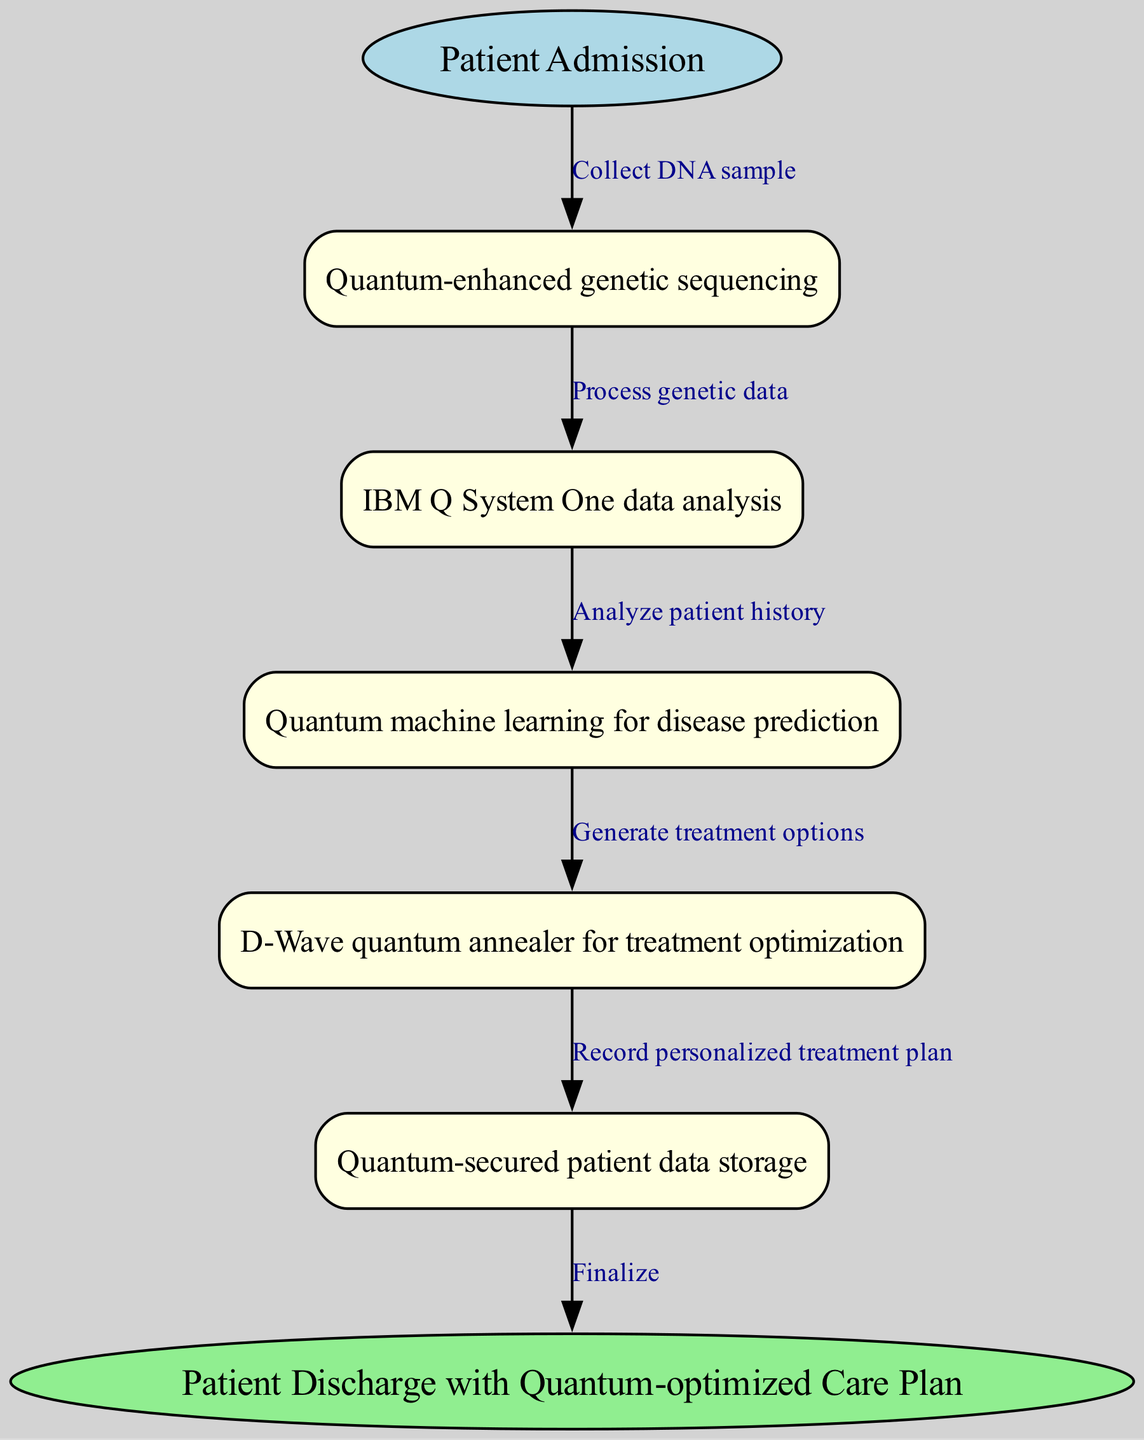What is the first step in the clinical pathway? The first step in the clinical pathway is labeled as "Patient Admission" and leads to the collection of a DNA sample.
Answer: Patient Admission How many nodes are in the diagram? The diagram contains five distinct nodes representing different processes in the pathway.
Answer: Five What is the relationship between "Quantum-enhanced genetic sequencing" and "IBM Q System One data analysis"? The relationship is that after collecting a DNA sample and performing quantum-enhanced genetic sequencing, the genetic data is processed by the IBM Q System One for analysis.
Answer: Process genetic data What does the D-Wave quantum annealer optimize? The D-Wave quantum annealer is used for optimizing treatment options based on the analysis performed in the earlier steps of the clinical pathway.
Answer: Treatment optimization What is recorded after generating a personalized treatment plan? After generating a personalized treatment plan, the outcome is recorded in the process of quantum-secured patient data storage.
Answer: Record personalized treatment plan How does quantum machine learning contribute to precision medicine in this pathway? Quantum machine learning is applied after analyzing patient history to predict potential diseases, which aids in tailoring treatment options in precision medicine.
Answer: Disease prediction What is the end result of this clinical pathway? The final output of the clinical pathway is the "Patient Discharge with Quantum-optimized Care Plan."
Answer: Patient Discharge with Quantum-optimized Care Plan What step follows the patient history analysis? The step that follows patient history analysis is the application of quantum machine learning for generating disease predictions.
Answer: Generate treatment options How does patient data management ensure security in this pathway? Patient data management is secured through quantum-secured patient data storage that protects the sensitive information collected during the pathway.
Answer: Quantum-secured patient data storage 